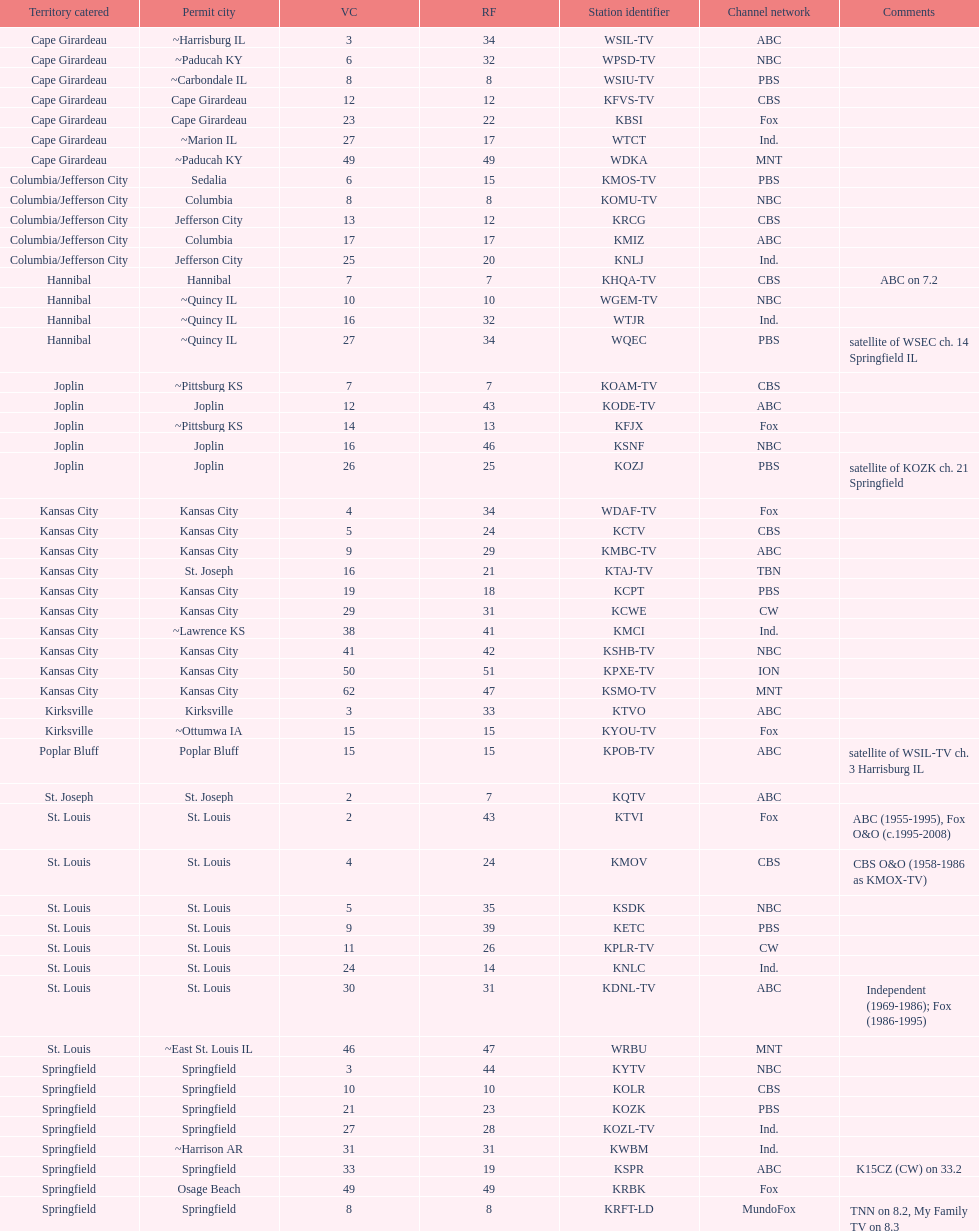How many are on the cbs network? 7. 